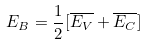Convert formula to latex. <formula><loc_0><loc_0><loc_500><loc_500>E _ { B } = \frac { 1 } { 2 } [ \overline { E _ { V } } + \overline { E _ { C } } ]</formula> 